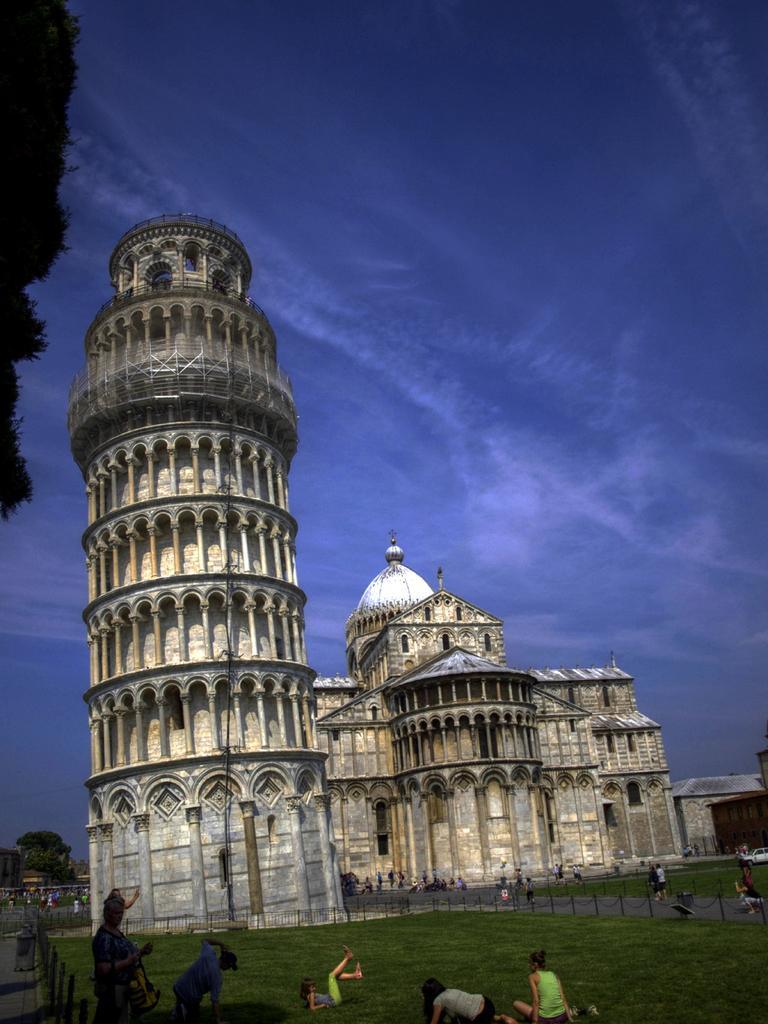Please provide a concise description of this image. In this picture we can see buildings with windows, fence, trees and a group of people on the ground and in the background we can see the sky with clouds. 